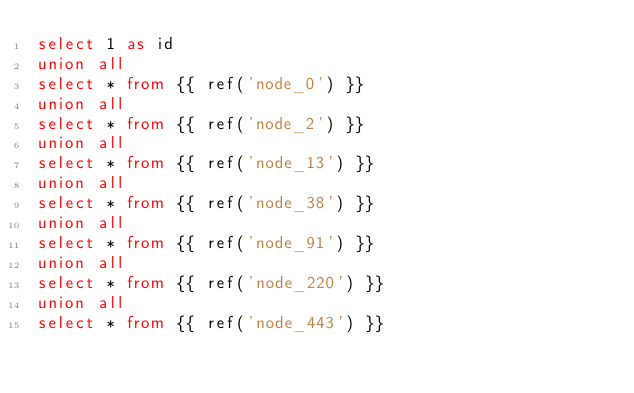Convert code to text. <code><loc_0><loc_0><loc_500><loc_500><_SQL_>select 1 as id
union all
select * from {{ ref('node_0') }}
union all
select * from {{ ref('node_2') }}
union all
select * from {{ ref('node_13') }}
union all
select * from {{ ref('node_38') }}
union all
select * from {{ ref('node_91') }}
union all
select * from {{ ref('node_220') }}
union all
select * from {{ ref('node_443') }}
</code> 